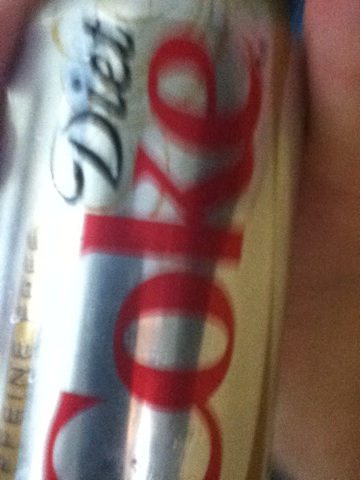what kind of soda is this please you guys are doing a great job. from Vizwiz The beverage in the image appears to be a can of Diet Coke. This is a sugar-free variant of the popular Coca-Cola soft drink, known for its distinctive silver can with red lettering. 